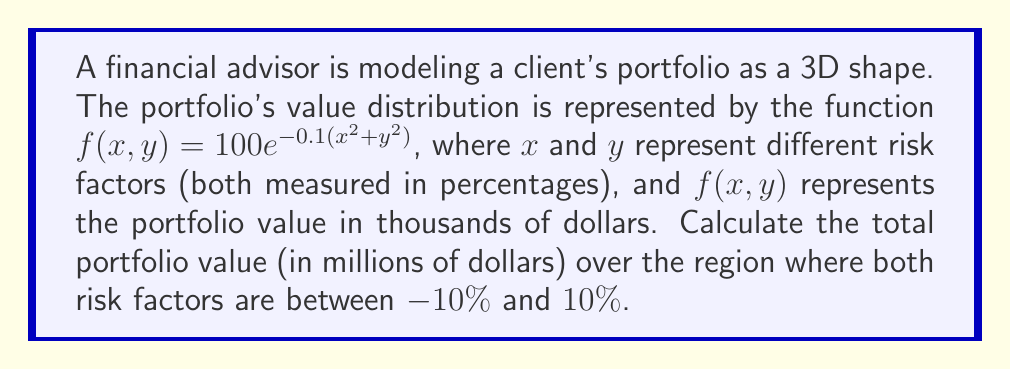Solve this math problem. To solve this problem, we need to use double integration to calculate the volume under the surface defined by $f(x,y)$ over the given region. Here's the step-by-step solution:

1) The volume we're looking for is given by the double integral:

   $$V = \int_{-10}^{10} \int_{-10}^{10} f(x,y) \, dy \, dx$$

2) Substituting the given function:

   $$V = \int_{-10}^{10} \int_{-10}^{10} 100e^{-0.1(x^2+y^2)} \, dy \, dx$$

3) This integral is symmetric in x and y, so we can evaluate it as:

   $$V = 100 \cdot \left(\int_{-10}^{10} e^{-0.1x^2} \, dx\right)^2$$

4) This is a standard Gaussian integral. We can evaluate it using the substitution $u = \sqrt{0.1}x$:

   $$\int_{-10}^{10} e^{-0.1x^2} \, dx = \frac{1}{\sqrt{0.1}} \int_{-10\sqrt{0.1}}^{10\sqrt{0.1}} e^{-u^2} \, du$$

5) The error function erf(x) is defined as:

   $$\text{erf}(x) = \frac{2}{\sqrt{\pi}} \int_0^x e^{-t^2} \, dt$$

6) Using this, we can express our integral as:

   $$\int_{-10}^{10} e^{-0.1x^2} \, dx = \frac{1}{\sqrt{0.1}} \cdot \sqrt{\pi} \cdot \text{erf}(10\sqrt{0.1})$$

7) Evaluating this numerically:

   $$\int_{-10}^{10} e^{-0.1x^2} \, dx \approx 9.9476$$

8) Therefore, the volume is:

   $$V \approx 100 \cdot (9.9476)^2 \approx 9895.27$$

9) This value is in thousands of dollars. To convert to millions, we divide by 1000:

   $$V \approx 9.89527 \text{ million dollars}$$
Answer: $9.89527$ million dollars 